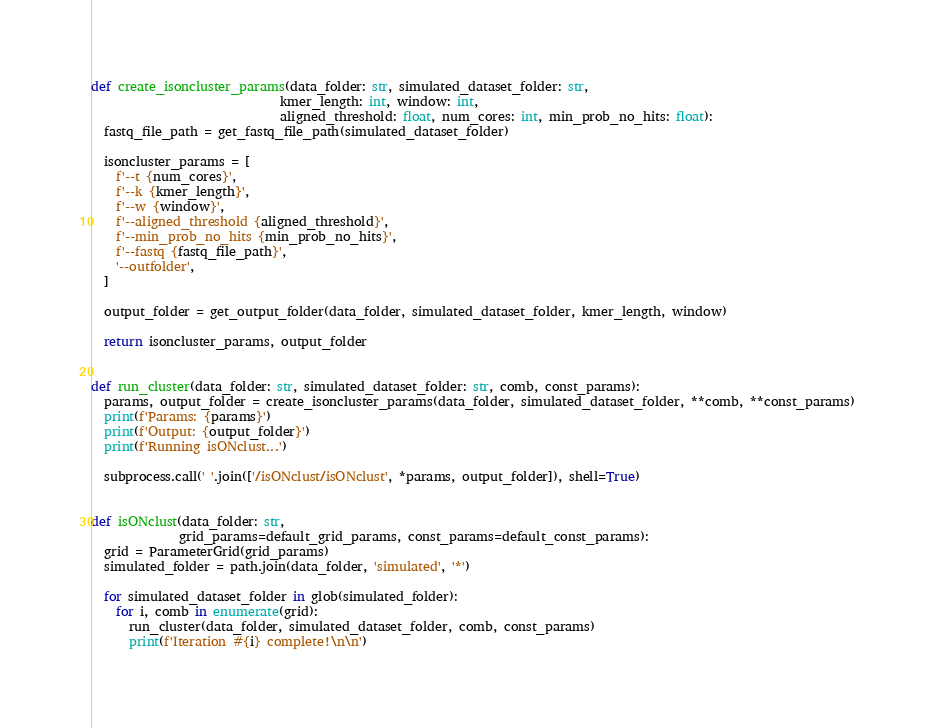<code> <loc_0><loc_0><loc_500><loc_500><_Python_>

def create_isoncluster_params(data_folder: str, simulated_dataset_folder: str,
                              kmer_length: int, window: int,
                              aligned_threshold: float, num_cores: int, min_prob_no_hits: float):
  fastq_file_path = get_fastq_file_path(simulated_dataset_folder)

  isoncluster_params = [
    f'--t {num_cores}',
    f'--k {kmer_length}',
    f'--w {window}',
    f'--aligned_threshold {aligned_threshold}',
    f'--min_prob_no_hits {min_prob_no_hits}',
    f'--fastq {fastq_file_path}',
    '--outfolder',
  ]

  output_folder = get_output_folder(data_folder, simulated_dataset_folder, kmer_length, window)
  
  return isoncluster_params, output_folder


def run_cluster(data_folder: str, simulated_dataset_folder: str, comb, const_params):
  params, output_folder = create_isoncluster_params(data_folder, simulated_dataset_folder, **comb, **const_params)
  print(f'Params: {params}')
  print(f'Output: {output_folder}')                                                   
  print(f'Running isONclust...')

  subprocess.call(' '.join(['/isONclust/isONclust', *params, output_folder]), shell=True)


def isONclust(data_folder: str, 
              grid_params=default_grid_params, const_params=default_const_params):
  grid = ParameterGrid(grid_params)
  simulated_folder = path.join(data_folder, 'simulated', '*')

  for simulated_dataset_folder in glob(simulated_folder):
    for i, comb in enumerate(grid):
      run_cluster(data_folder, simulated_dataset_folder, comb, const_params)
      print(f'Iteration #{i} complete!\n\n')
</code> 